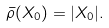<formula> <loc_0><loc_0><loc_500><loc_500>\bar { \rho } ( X _ { 0 } ) = | X _ { 0 } | .</formula> 